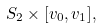Convert formula to latex. <formula><loc_0><loc_0><loc_500><loc_500>S _ { 2 } \times [ v _ { 0 } , v _ { 1 } ] ,</formula> 